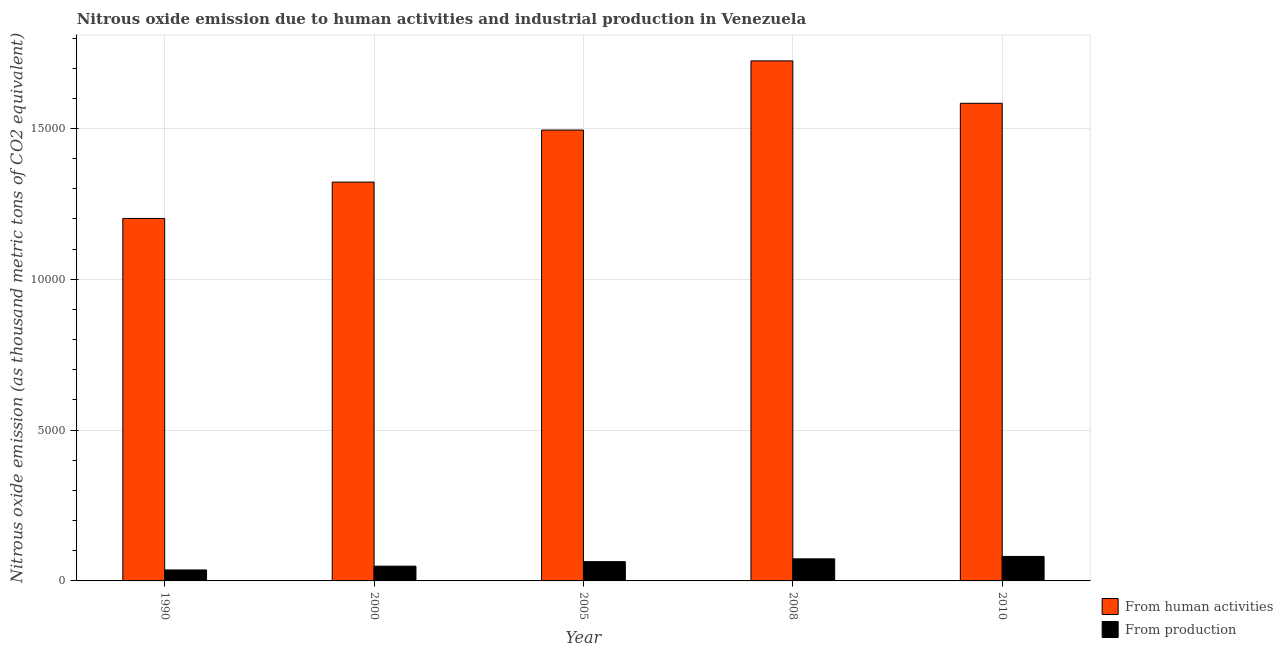How many different coloured bars are there?
Your response must be concise. 2. What is the amount of emissions generated from industries in 2005?
Keep it short and to the point. 639.1. Across all years, what is the maximum amount of emissions generated from industries?
Give a very brief answer. 811.9. Across all years, what is the minimum amount of emissions from human activities?
Provide a short and direct response. 1.20e+04. In which year was the amount of emissions generated from industries maximum?
Keep it short and to the point. 2010. In which year was the amount of emissions generated from industries minimum?
Provide a short and direct response. 1990. What is the total amount of emissions from human activities in the graph?
Offer a terse response. 7.33e+04. What is the difference between the amount of emissions from human activities in 1990 and that in 2005?
Provide a short and direct response. -2931.2. What is the difference between the amount of emissions from human activities in 2000 and the amount of emissions generated from industries in 2005?
Your response must be concise. -1725.4. What is the average amount of emissions from human activities per year?
Provide a succinct answer. 1.47e+04. In how many years, is the amount of emissions generated from industries greater than 10000 thousand metric tons?
Make the answer very short. 0. What is the ratio of the amount of emissions generated from industries in 2000 to that in 2005?
Your response must be concise. 0.77. Is the difference between the amount of emissions from human activities in 2005 and 2008 greater than the difference between the amount of emissions generated from industries in 2005 and 2008?
Your answer should be very brief. No. What is the difference between the highest and the second highest amount of emissions generated from industries?
Provide a short and direct response. 80.3. What is the difference between the highest and the lowest amount of emissions from human activities?
Your answer should be compact. 5224.6. What does the 1st bar from the left in 2000 represents?
Ensure brevity in your answer.  From human activities. What does the 1st bar from the right in 2010 represents?
Your answer should be very brief. From production. How many bars are there?
Keep it short and to the point. 10. How many years are there in the graph?
Provide a short and direct response. 5. Are the values on the major ticks of Y-axis written in scientific E-notation?
Provide a short and direct response. No. How many legend labels are there?
Ensure brevity in your answer.  2. How are the legend labels stacked?
Provide a short and direct response. Vertical. What is the title of the graph?
Provide a short and direct response. Nitrous oxide emission due to human activities and industrial production in Venezuela. What is the label or title of the Y-axis?
Offer a very short reply. Nitrous oxide emission (as thousand metric tons of CO2 equivalent). What is the Nitrous oxide emission (as thousand metric tons of CO2 equivalent) in From human activities in 1990?
Provide a short and direct response. 1.20e+04. What is the Nitrous oxide emission (as thousand metric tons of CO2 equivalent) in From production in 1990?
Keep it short and to the point. 363.6. What is the Nitrous oxide emission (as thousand metric tons of CO2 equivalent) in From human activities in 2000?
Give a very brief answer. 1.32e+04. What is the Nitrous oxide emission (as thousand metric tons of CO2 equivalent) in From production in 2000?
Keep it short and to the point. 489.3. What is the Nitrous oxide emission (as thousand metric tons of CO2 equivalent) of From human activities in 2005?
Give a very brief answer. 1.49e+04. What is the Nitrous oxide emission (as thousand metric tons of CO2 equivalent) in From production in 2005?
Your answer should be very brief. 639.1. What is the Nitrous oxide emission (as thousand metric tons of CO2 equivalent) of From human activities in 2008?
Provide a short and direct response. 1.72e+04. What is the Nitrous oxide emission (as thousand metric tons of CO2 equivalent) in From production in 2008?
Your answer should be compact. 731.6. What is the Nitrous oxide emission (as thousand metric tons of CO2 equivalent) of From human activities in 2010?
Your answer should be compact. 1.58e+04. What is the Nitrous oxide emission (as thousand metric tons of CO2 equivalent) of From production in 2010?
Your response must be concise. 811.9. Across all years, what is the maximum Nitrous oxide emission (as thousand metric tons of CO2 equivalent) of From human activities?
Your response must be concise. 1.72e+04. Across all years, what is the maximum Nitrous oxide emission (as thousand metric tons of CO2 equivalent) of From production?
Provide a succinct answer. 811.9. Across all years, what is the minimum Nitrous oxide emission (as thousand metric tons of CO2 equivalent) in From human activities?
Your answer should be very brief. 1.20e+04. Across all years, what is the minimum Nitrous oxide emission (as thousand metric tons of CO2 equivalent) in From production?
Your response must be concise. 363.6. What is the total Nitrous oxide emission (as thousand metric tons of CO2 equivalent) of From human activities in the graph?
Offer a very short reply. 7.33e+04. What is the total Nitrous oxide emission (as thousand metric tons of CO2 equivalent) in From production in the graph?
Give a very brief answer. 3035.5. What is the difference between the Nitrous oxide emission (as thousand metric tons of CO2 equivalent) of From human activities in 1990 and that in 2000?
Your answer should be very brief. -1205.8. What is the difference between the Nitrous oxide emission (as thousand metric tons of CO2 equivalent) of From production in 1990 and that in 2000?
Provide a succinct answer. -125.7. What is the difference between the Nitrous oxide emission (as thousand metric tons of CO2 equivalent) in From human activities in 1990 and that in 2005?
Make the answer very short. -2931.2. What is the difference between the Nitrous oxide emission (as thousand metric tons of CO2 equivalent) of From production in 1990 and that in 2005?
Offer a very short reply. -275.5. What is the difference between the Nitrous oxide emission (as thousand metric tons of CO2 equivalent) of From human activities in 1990 and that in 2008?
Make the answer very short. -5224.6. What is the difference between the Nitrous oxide emission (as thousand metric tons of CO2 equivalent) in From production in 1990 and that in 2008?
Your answer should be compact. -368. What is the difference between the Nitrous oxide emission (as thousand metric tons of CO2 equivalent) in From human activities in 1990 and that in 2010?
Ensure brevity in your answer.  -3818.1. What is the difference between the Nitrous oxide emission (as thousand metric tons of CO2 equivalent) in From production in 1990 and that in 2010?
Provide a short and direct response. -448.3. What is the difference between the Nitrous oxide emission (as thousand metric tons of CO2 equivalent) in From human activities in 2000 and that in 2005?
Make the answer very short. -1725.4. What is the difference between the Nitrous oxide emission (as thousand metric tons of CO2 equivalent) in From production in 2000 and that in 2005?
Your answer should be very brief. -149.8. What is the difference between the Nitrous oxide emission (as thousand metric tons of CO2 equivalent) of From human activities in 2000 and that in 2008?
Your answer should be very brief. -4018.8. What is the difference between the Nitrous oxide emission (as thousand metric tons of CO2 equivalent) in From production in 2000 and that in 2008?
Keep it short and to the point. -242.3. What is the difference between the Nitrous oxide emission (as thousand metric tons of CO2 equivalent) in From human activities in 2000 and that in 2010?
Make the answer very short. -2612.3. What is the difference between the Nitrous oxide emission (as thousand metric tons of CO2 equivalent) of From production in 2000 and that in 2010?
Your answer should be compact. -322.6. What is the difference between the Nitrous oxide emission (as thousand metric tons of CO2 equivalent) in From human activities in 2005 and that in 2008?
Provide a short and direct response. -2293.4. What is the difference between the Nitrous oxide emission (as thousand metric tons of CO2 equivalent) in From production in 2005 and that in 2008?
Give a very brief answer. -92.5. What is the difference between the Nitrous oxide emission (as thousand metric tons of CO2 equivalent) of From human activities in 2005 and that in 2010?
Offer a very short reply. -886.9. What is the difference between the Nitrous oxide emission (as thousand metric tons of CO2 equivalent) in From production in 2005 and that in 2010?
Your answer should be compact. -172.8. What is the difference between the Nitrous oxide emission (as thousand metric tons of CO2 equivalent) of From human activities in 2008 and that in 2010?
Offer a very short reply. 1406.5. What is the difference between the Nitrous oxide emission (as thousand metric tons of CO2 equivalent) in From production in 2008 and that in 2010?
Your answer should be very brief. -80.3. What is the difference between the Nitrous oxide emission (as thousand metric tons of CO2 equivalent) in From human activities in 1990 and the Nitrous oxide emission (as thousand metric tons of CO2 equivalent) in From production in 2000?
Provide a succinct answer. 1.15e+04. What is the difference between the Nitrous oxide emission (as thousand metric tons of CO2 equivalent) of From human activities in 1990 and the Nitrous oxide emission (as thousand metric tons of CO2 equivalent) of From production in 2005?
Keep it short and to the point. 1.14e+04. What is the difference between the Nitrous oxide emission (as thousand metric tons of CO2 equivalent) in From human activities in 1990 and the Nitrous oxide emission (as thousand metric tons of CO2 equivalent) in From production in 2008?
Ensure brevity in your answer.  1.13e+04. What is the difference between the Nitrous oxide emission (as thousand metric tons of CO2 equivalent) in From human activities in 1990 and the Nitrous oxide emission (as thousand metric tons of CO2 equivalent) in From production in 2010?
Ensure brevity in your answer.  1.12e+04. What is the difference between the Nitrous oxide emission (as thousand metric tons of CO2 equivalent) in From human activities in 2000 and the Nitrous oxide emission (as thousand metric tons of CO2 equivalent) in From production in 2005?
Make the answer very short. 1.26e+04. What is the difference between the Nitrous oxide emission (as thousand metric tons of CO2 equivalent) in From human activities in 2000 and the Nitrous oxide emission (as thousand metric tons of CO2 equivalent) in From production in 2008?
Provide a succinct answer. 1.25e+04. What is the difference between the Nitrous oxide emission (as thousand metric tons of CO2 equivalent) in From human activities in 2000 and the Nitrous oxide emission (as thousand metric tons of CO2 equivalent) in From production in 2010?
Provide a short and direct response. 1.24e+04. What is the difference between the Nitrous oxide emission (as thousand metric tons of CO2 equivalent) in From human activities in 2005 and the Nitrous oxide emission (as thousand metric tons of CO2 equivalent) in From production in 2008?
Provide a succinct answer. 1.42e+04. What is the difference between the Nitrous oxide emission (as thousand metric tons of CO2 equivalent) in From human activities in 2005 and the Nitrous oxide emission (as thousand metric tons of CO2 equivalent) in From production in 2010?
Your response must be concise. 1.41e+04. What is the difference between the Nitrous oxide emission (as thousand metric tons of CO2 equivalent) of From human activities in 2008 and the Nitrous oxide emission (as thousand metric tons of CO2 equivalent) of From production in 2010?
Make the answer very short. 1.64e+04. What is the average Nitrous oxide emission (as thousand metric tons of CO2 equivalent) in From human activities per year?
Offer a very short reply. 1.47e+04. What is the average Nitrous oxide emission (as thousand metric tons of CO2 equivalent) in From production per year?
Provide a succinct answer. 607.1. In the year 1990, what is the difference between the Nitrous oxide emission (as thousand metric tons of CO2 equivalent) of From human activities and Nitrous oxide emission (as thousand metric tons of CO2 equivalent) of From production?
Your response must be concise. 1.17e+04. In the year 2000, what is the difference between the Nitrous oxide emission (as thousand metric tons of CO2 equivalent) in From human activities and Nitrous oxide emission (as thousand metric tons of CO2 equivalent) in From production?
Make the answer very short. 1.27e+04. In the year 2005, what is the difference between the Nitrous oxide emission (as thousand metric tons of CO2 equivalent) in From human activities and Nitrous oxide emission (as thousand metric tons of CO2 equivalent) in From production?
Make the answer very short. 1.43e+04. In the year 2008, what is the difference between the Nitrous oxide emission (as thousand metric tons of CO2 equivalent) in From human activities and Nitrous oxide emission (as thousand metric tons of CO2 equivalent) in From production?
Provide a short and direct response. 1.65e+04. In the year 2010, what is the difference between the Nitrous oxide emission (as thousand metric tons of CO2 equivalent) of From human activities and Nitrous oxide emission (as thousand metric tons of CO2 equivalent) of From production?
Give a very brief answer. 1.50e+04. What is the ratio of the Nitrous oxide emission (as thousand metric tons of CO2 equivalent) in From human activities in 1990 to that in 2000?
Make the answer very short. 0.91. What is the ratio of the Nitrous oxide emission (as thousand metric tons of CO2 equivalent) of From production in 1990 to that in 2000?
Your answer should be very brief. 0.74. What is the ratio of the Nitrous oxide emission (as thousand metric tons of CO2 equivalent) of From human activities in 1990 to that in 2005?
Offer a very short reply. 0.8. What is the ratio of the Nitrous oxide emission (as thousand metric tons of CO2 equivalent) in From production in 1990 to that in 2005?
Ensure brevity in your answer.  0.57. What is the ratio of the Nitrous oxide emission (as thousand metric tons of CO2 equivalent) in From human activities in 1990 to that in 2008?
Offer a very short reply. 0.7. What is the ratio of the Nitrous oxide emission (as thousand metric tons of CO2 equivalent) of From production in 1990 to that in 2008?
Make the answer very short. 0.5. What is the ratio of the Nitrous oxide emission (as thousand metric tons of CO2 equivalent) of From human activities in 1990 to that in 2010?
Your response must be concise. 0.76. What is the ratio of the Nitrous oxide emission (as thousand metric tons of CO2 equivalent) of From production in 1990 to that in 2010?
Provide a succinct answer. 0.45. What is the ratio of the Nitrous oxide emission (as thousand metric tons of CO2 equivalent) of From human activities in 2000 to that in 2005?
Provide a short and direct response. 0.88. What is the ratio of the Nitrous oxide emission (as thousand metric tons of CO2 equivalent) in From production in 2000 to that in 2005?
Provide a short and direct response. 0.77. What is the ratio of the Nitrous oxide emission (as thousand metric tons of CO2 equivalent) of From human activities in 2000 to that in 2008?
Provide a short and direct response. 0.77. What is the ratio of the Nitrous oxide emission (as thousand metric tons of CO2 equivalent) in From production in 2000 to that in 2008?
Keep it short and to the point. 0.67. What is the ratio of the Nitrous oxide emission (as thousand metric tons of CO2 equivalent) of From human activities in 2000 to that in 2010?
Give a very brief answer. 0.83. What is the ratio of the Nitrous oxide emission (as thousand metric tons of CO2 equivalent) in From production in 2000 to that in 2010?
Provide a succinct answer. 0.6. What is the ratio of the Nitrous oxide emission (as thousand metric tons of CO2 equivalent) of From human activities in 2005 to that in 2008?
Offer a terse response. 0.87. What is the ratio of the Nitrous oxide emission (as thousand metric tons of CO2 equivalent) in From production in 2005 to that in 2008?
Offer a very short reply. 0.87. What is the ratio of the Nitrous oxide emission (as thousand metric tons of CO2 equivalent) of From human activities in 2005 to that in 2010?
Your answer should be compact. 0.94. What is the ratio of the Nitrous oxide emission (as thousand metric tons of CO2 equivalent) of From production in 2005 to that in 2010?
Ensure brevity in your answer.  0.79. What is the ratio of the Nitrous oxide emission (as thousand metric tons of CO2 equivalent) of From human activities in 2008 to that in 2010?
Your answer should be compact. 1.09. What is the ratio of the Nitrous oxide emission (as thousand metric tons of CO2 equivalent) in From production in 2008 to that in 2010?
Give a very brief answer. 0.9. What is the difference between the highest and the second highest Nitrous oxide emission (as thousand metric tons of CO2 equivalent) of From human activities?
Give a very brief answer. 1406.5. What is the difference between the highest and the second highest Nitrous oxide emission (as thousand metric tons of CO2 equivalent) of From production?
Make the answer very short. 80.3. What is the difference between the highest and the lowest Nitrous oxide emission (as thousand metric tons of CO2 equivalent) of From human activities?
Give a very brief answer. 5224.6. What is the difference between the highest and the lowest Nitrous oxide emission (as thousand metric tons of CO2 equivalent) of From production?
Make the answer very short. 448.3. 